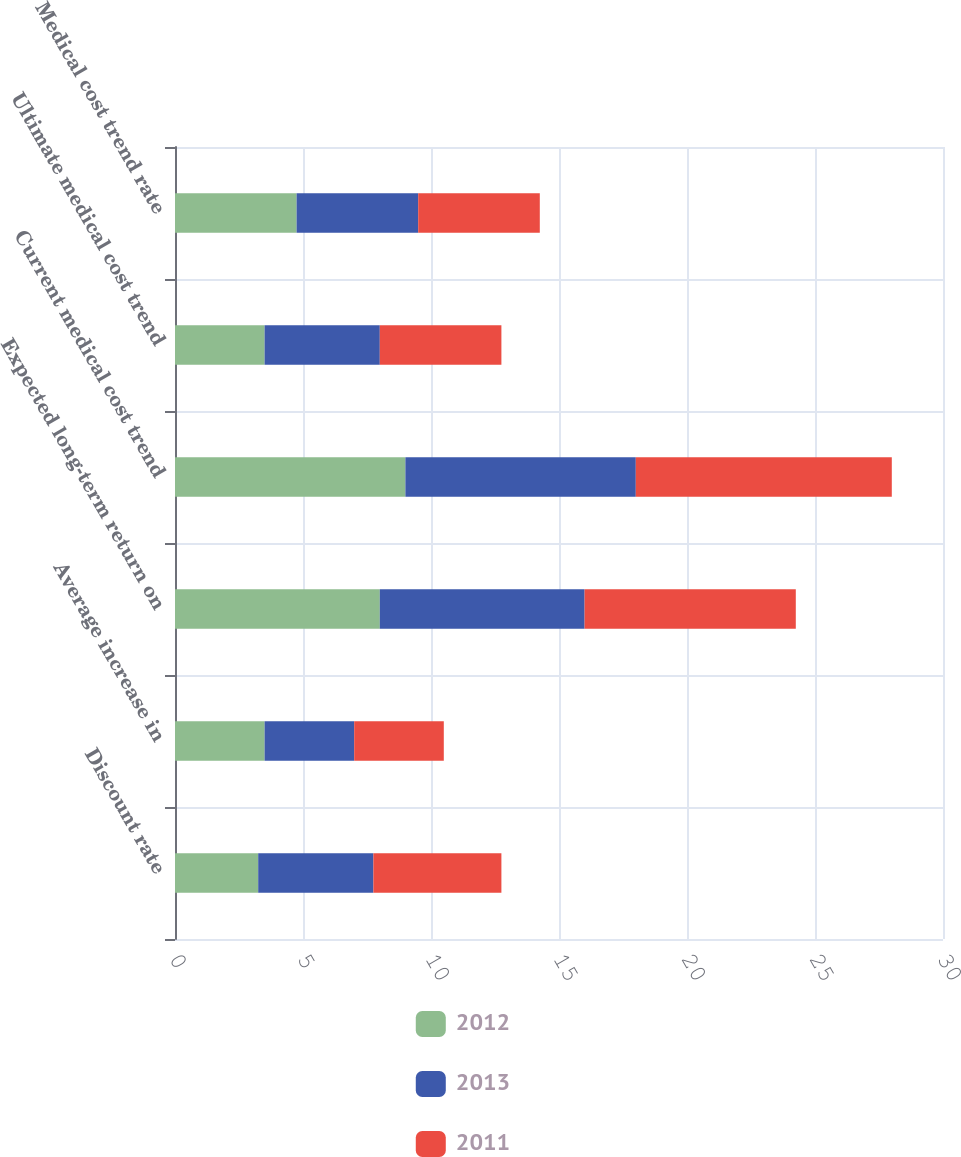Convert chart to OTSL. <chart><loc_0><loc_0><loc_500><loc_500><stacked_bar_chart><ecel><fcel>Discount rate<fcel>Average increase in<fcel>Expected long-term return on<fcel>Current medical cost trend<fcel>Ultimate medical cost trend<fcel>Medical cost trend rate<nl><fcel>2012<fcel>3.25<fcel>3.5<fcel>8<fcel>9<fcel>3.5<fcel>4.75<nl><fcel>2013<fcel>4.5<fcel>3.5<fcel>8<fcel>9<fcel>4.5<fcel>4.75<nl><fcel>2011<fcel>5<fcel>3.5<fcel>8.25<fcel>10<fcel>4.75<fcel>4.75<nl></chart> 